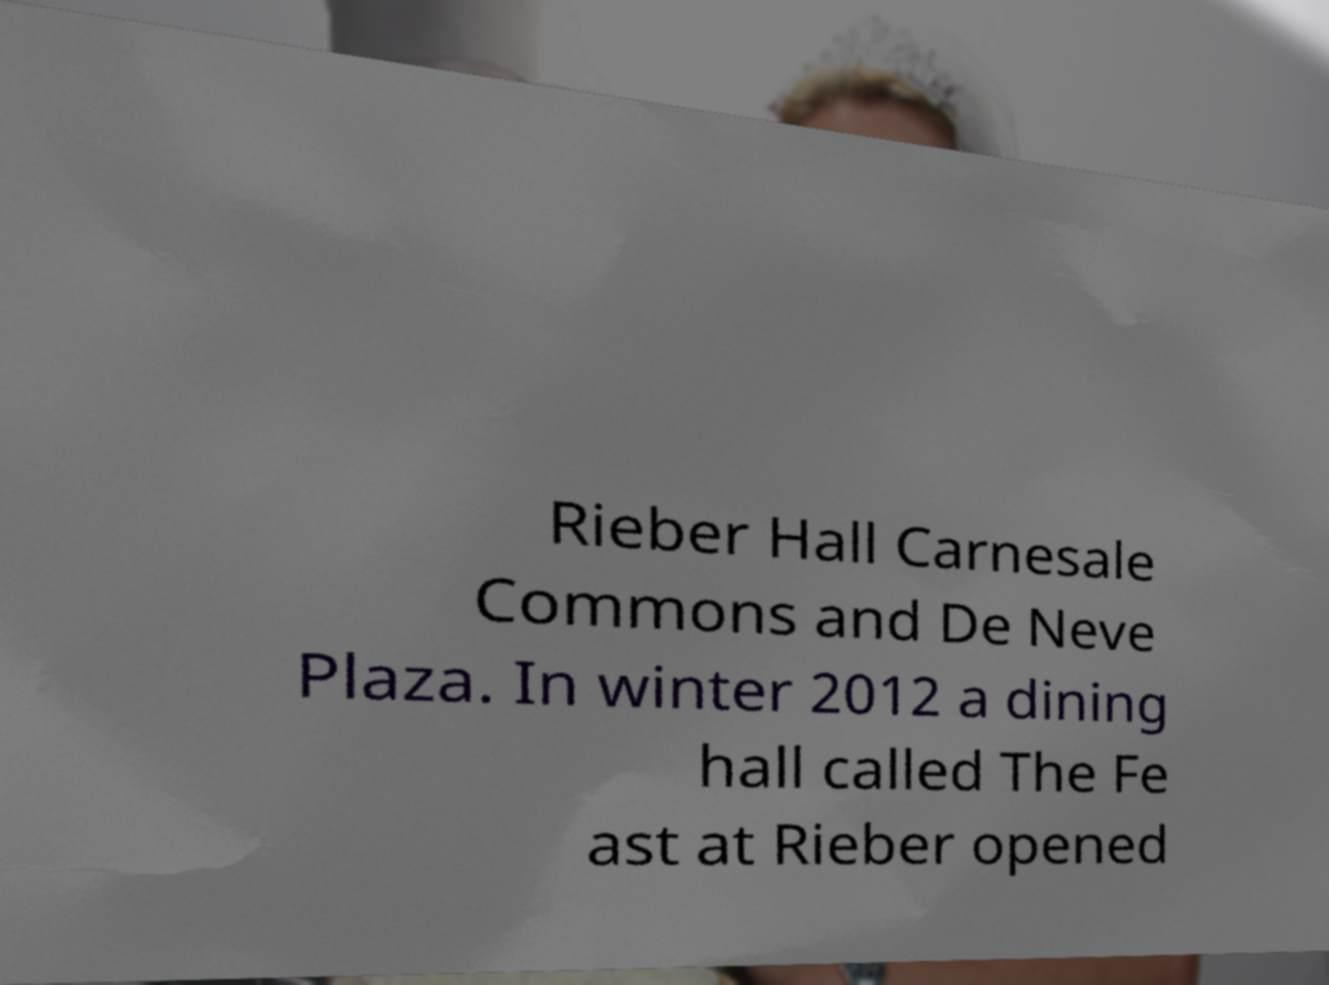There's text embedded in this image that I need extracted. Can you transcribe it verbatim? Rieber Hall Carnesale Commons and De Neve Plaza. In winter 2012 a dining hall called The Fe ast at Rieber opened 